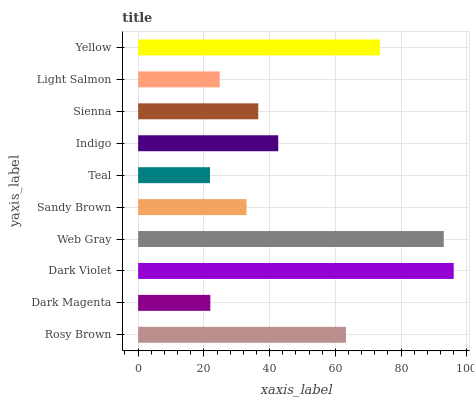Is Teal the minimum?
Answer yes or no. Yes. Is Dark Violet the maximum?
Answer yes or no. Yes. Is Dark Magenta the minimum?
Answer yes or no. No. Is Dark Magenta the maximum?
Answer yes or no. No. Is Rosy Brown greater than Dark Magenta?
Answer yes or no. Yes. Is Dark Magenta less than Rosy Brown?
Answer yes or no. Yes. Is Dark Magenta greater than Rosy Brown?
Answer yes or no. No. Is Rosy Brown less than Dark Magenta?
Answer yes or no. No. Is Indigo the high median?
Answer yes or no. Yes. Is Sienna the low median?
Answer yes or no. Yes. Is Dark Violet the high median?
Answer yes or no. No. Is Teal the low median?
Answer yes or no. No. 